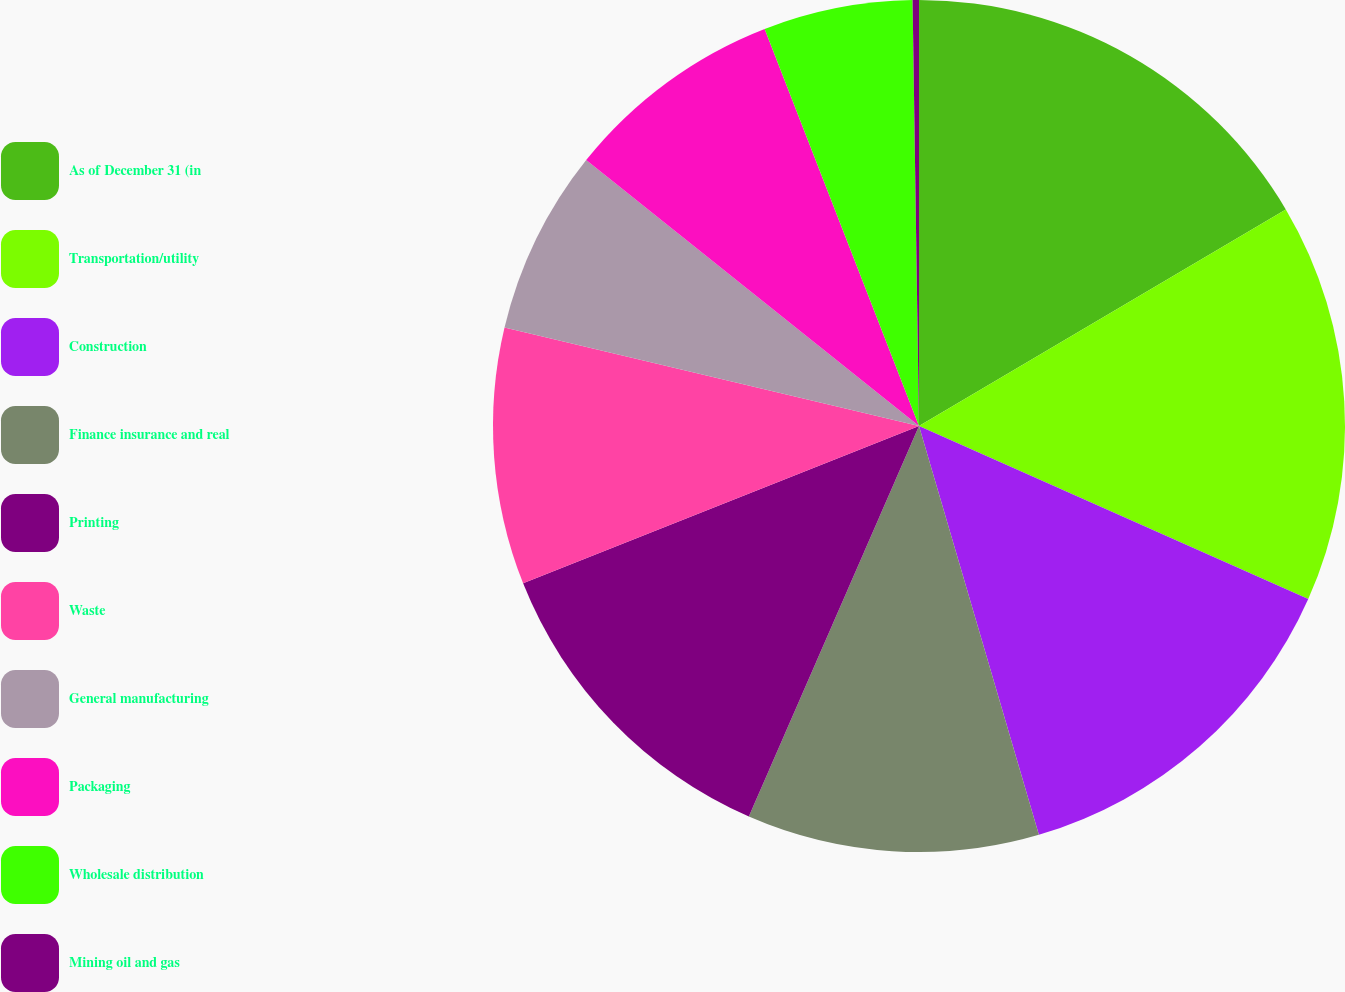Convert chart to OTSL. <chart><loc_0><loc_0><loc_500><loc_500><pie_chart><fcel>As of December 31 (in<fcel>Transportation/utility<fcel>Construction<fcel>Finance insurance and real<fcel>Printing<fcel>Waste<fcel>General manufacturing<fcel>Packaging<fcel>Wholesale distribution<fcel>Mining oil and gas<nl><fcel>16.51%<fcel>15.15%<fcel>13.8%<fcel>11.08%<fcel>12.44%<fcel>9.73%<fcel>7.02%<fcel>8.37%<fcel>5.66%<fcel>0.24%<nl></chart> 